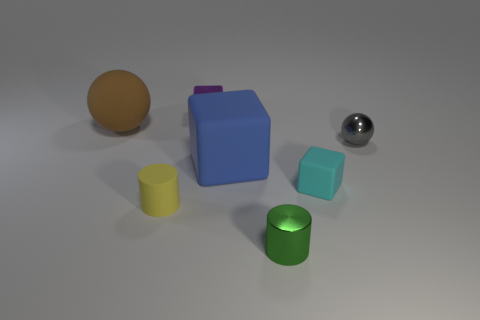Are there any reflective surfaces in the image? Yes, the spherical object on the right-hand side has a highly reflective surface, suggesting it's made of metal or a polished material, as it reflects the environment and the object itself. 